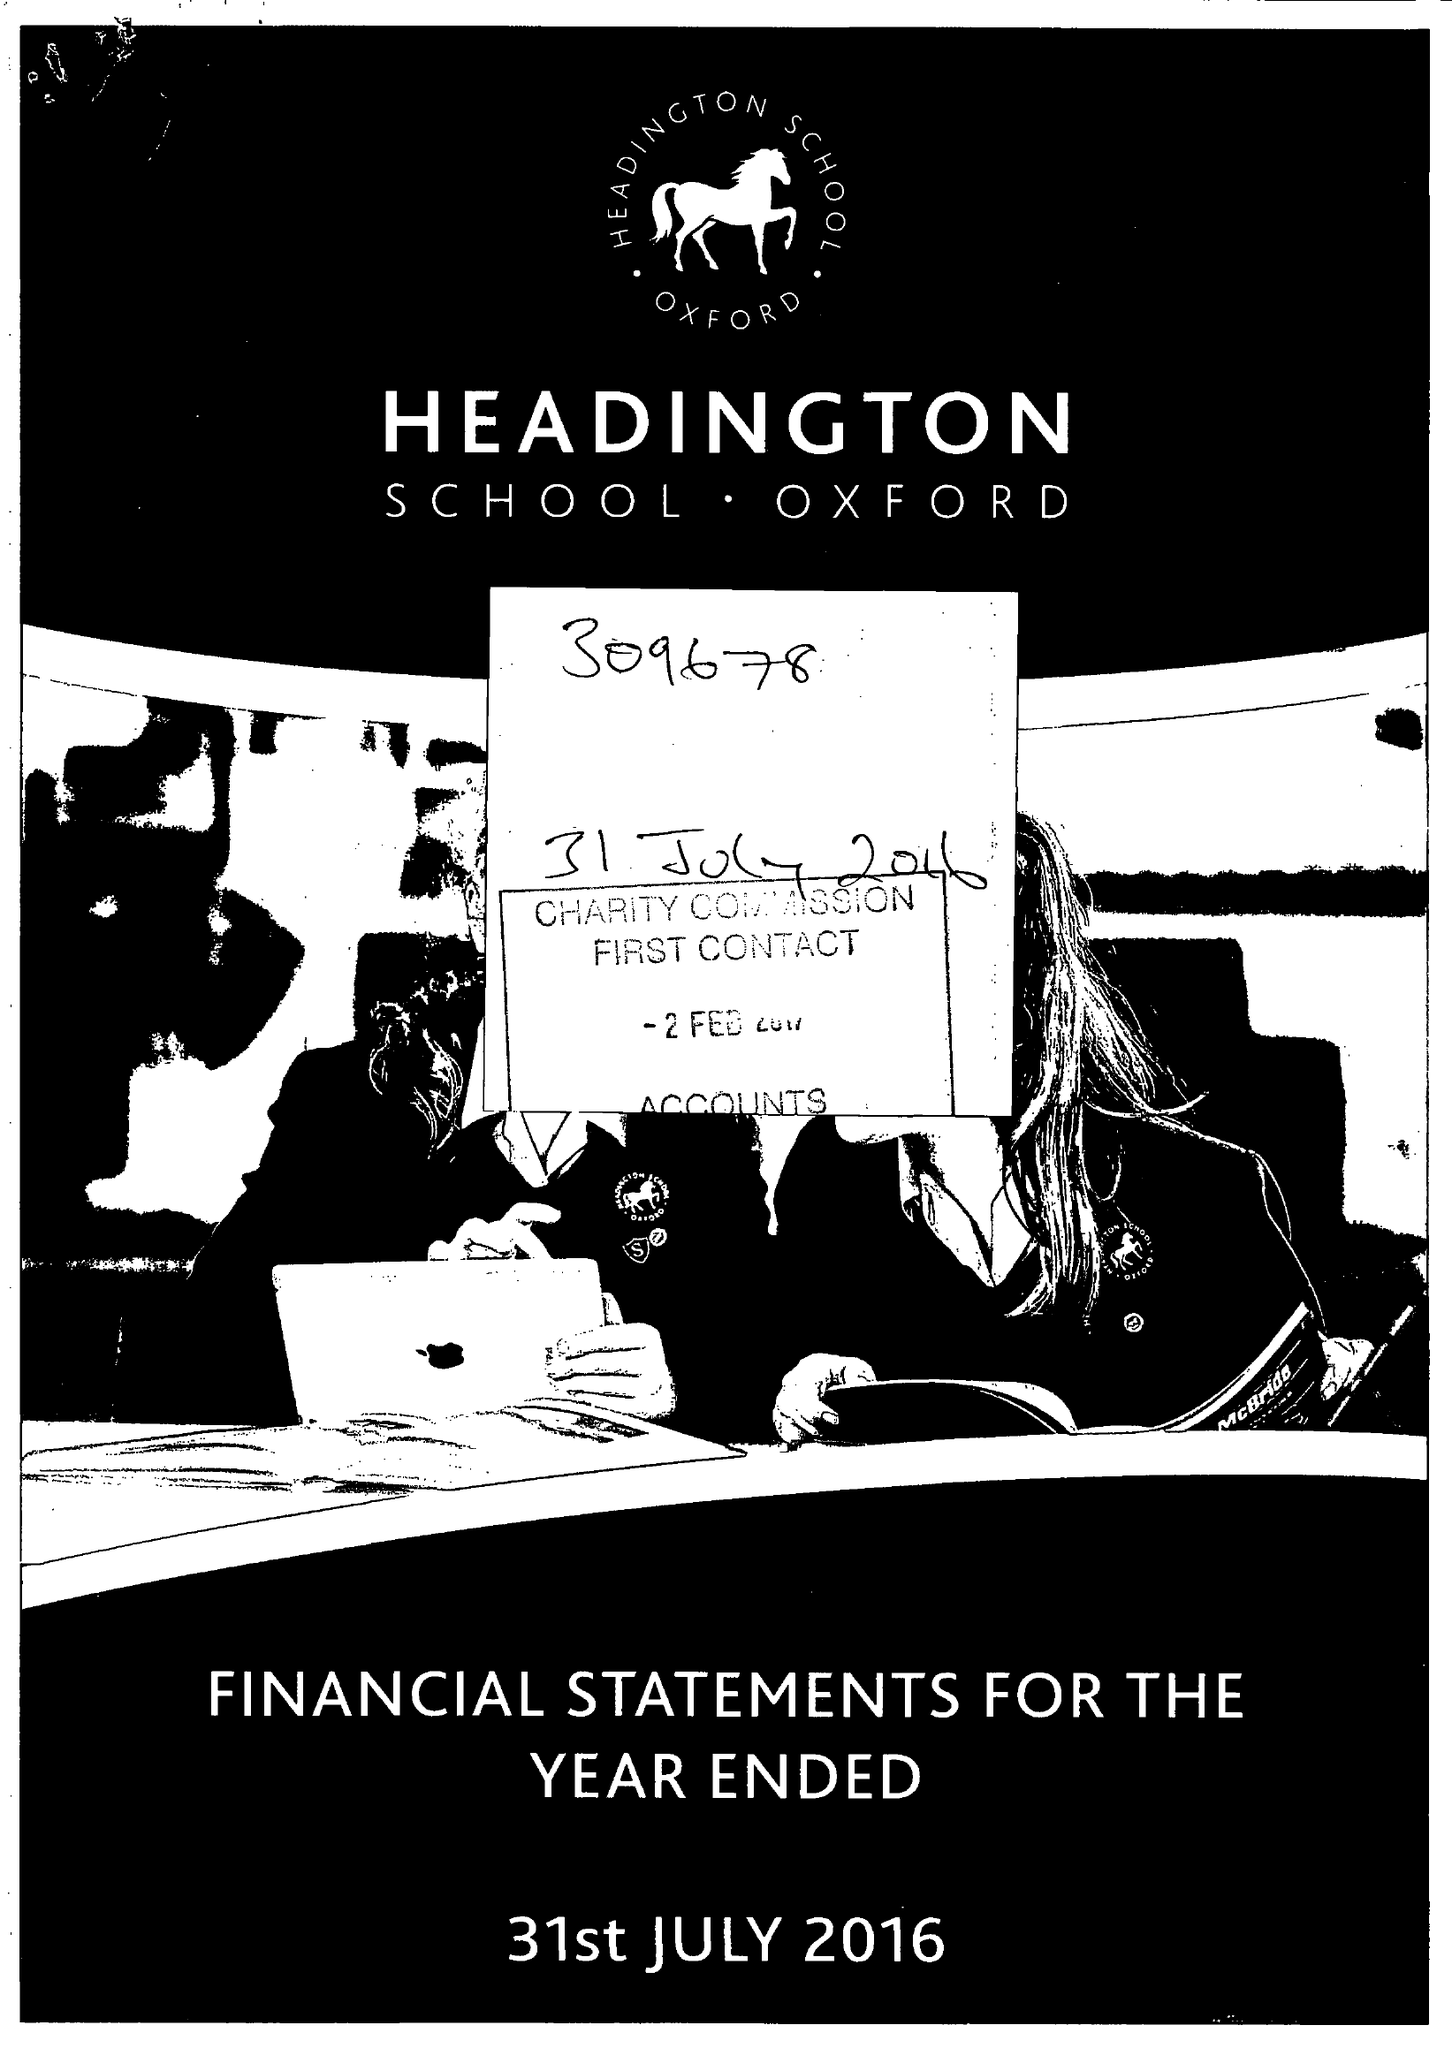What is the value for the address__post_town?
Answer the question using a single word or phrase. OXFORD 